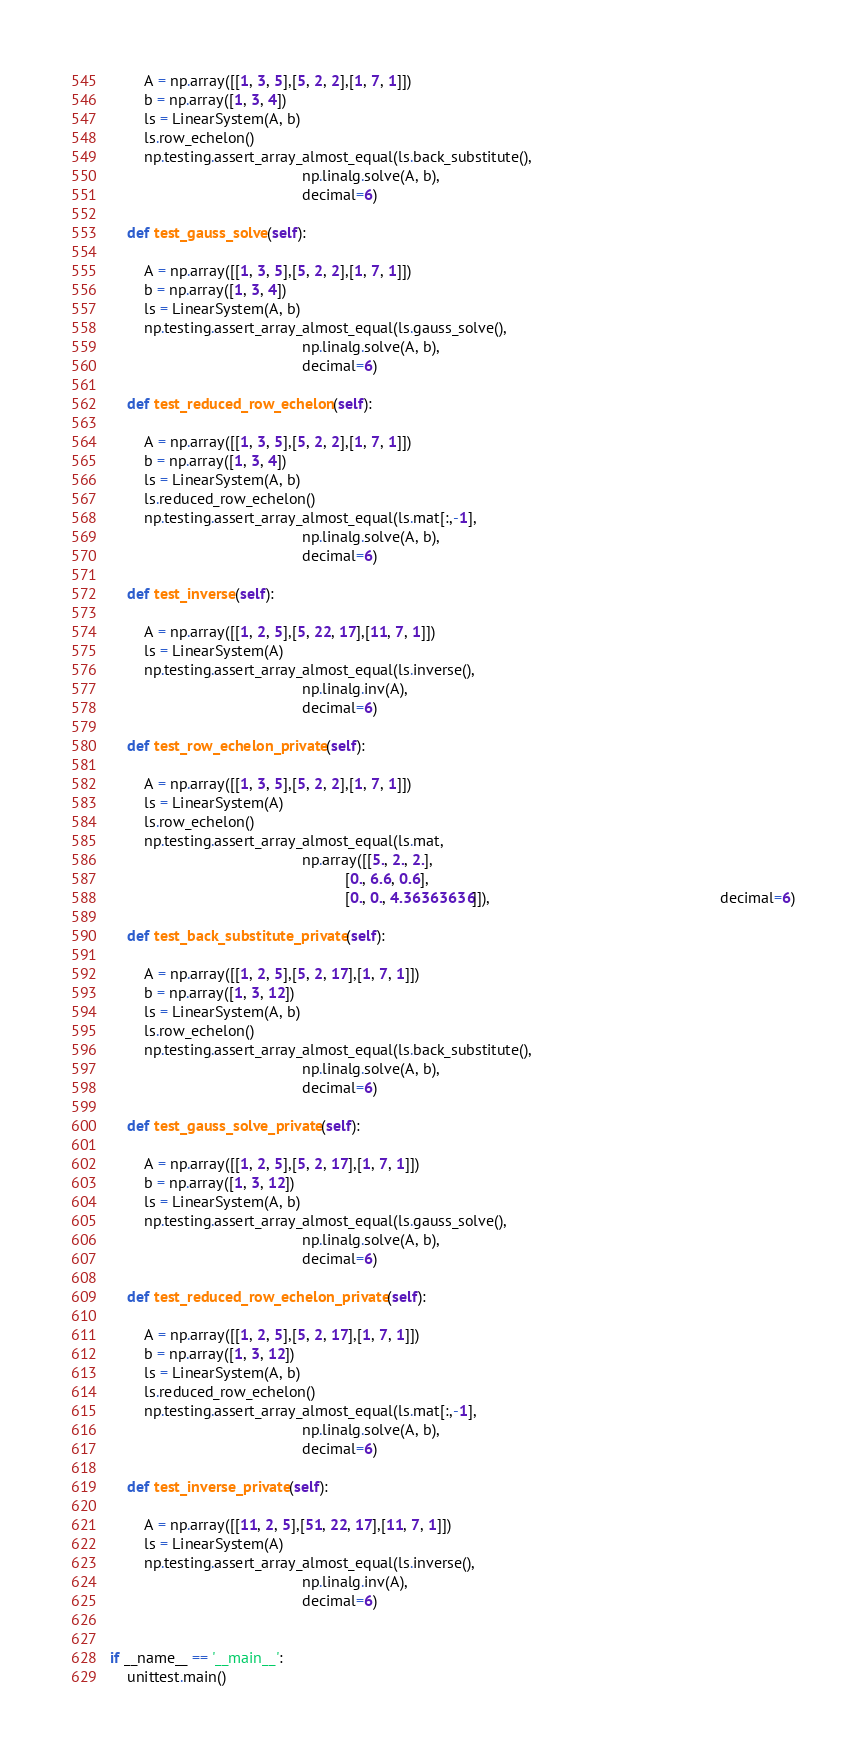Convert code to text. <code><loc_0><loc_0><loc_500><loc_500><_Python_>        A = np.array([[1, 3, 5],[5, 2, 2],[1, 7, 1]])
        b = np.array([1, 3, 4])
        ls = LinearSystem(A, b)
        ls.row_echelon()
        np.testing.assert_array_almost_equal(ls.back_substitute(),
                                             np.linalg.solve(A, b),
                                             decimal=6)
        
    def test_gauss_solve(self):
        
        A = np.array([[1, 3, 5],[5, 2, 2],[1, 7, 1]])
        b = np.array([1, 3, 4])
        ls = LinearSystem(A, b)
        np.testing.assert_array_almost_equal(ls.gauss_solve(),
                                             np.linalg.solve(A, b),
                                             decimal=6)
        
    def test_reduced_row_echelon(self):
        
        A = np.array([[1, 3, 5],[5, 2, 2],[1, 7, 1]])
        b = np.array([1, 3, 4])
        ls = LinearSystem(A, b)
        ls.reduced_row_echelon()
        np.testing.assert_array_almost_equal(ls.mat[:,-1],
                                             np.linalg.solve(A, b),
                                             decimal=6)
        
    def test_inverse(self):
        
        A = np.array([[1, 2, 5],[5, 22, 17],[11, 7, 1]])
        ls = LinearSystem(A)
        np.testing.assert_array_almost_equal(ls.inverse(),
                                             np.linalg.inv(A),
                                             decimal=6)
        
    def test_row_echelon_private(self):
        
        A = np.array([[1, 3, 5],[5, 2, 2],[1, 7, 1]])
        ls = LinearSystem(A)
        ls.row_echelon() 
        np.testing.assert_array_almost_equal(ls.mat, 
                                             np.array([[5., 2., 2.],
                                                       [0., 6.6, 0.6],
                                                       [0., 0., 4.36363636]]),                                                      decimal=6)
        
    def test_back_substitute_private(self):
        
        A = np.array([[1, 2, 5],[5, 2, 17],[1, 7, 1]])
        b = np.array([1, 3, 12])
        ls = LinearSystem(A, b)
        ls.row_echelon()
        np.testing.assert_array_almost_equal(ls.back_substitute(),
                                             np.linalg.solve(A, b),
                                             decimal=6)
        
    def test_gauss_solve_private(self):
        
        A = np.array([[1, 2, 5],[5, 2, 17],[1, 7, 1]])
        b = np.array([1, 3, 12])
        ls = LinearSystem(A, b)
        np.testing.assert_array_almost_equal(ls.gauss_solve(),
                                             np.linalg.solve(A, b),
                                             decimal=6)
        
    def test_reduced_row_echelon_private(self):
        
        A = np.array([[1, 2, 5],[5, 2, 17],[1, 7, 1]])
        b = np.array([1, 3, 12])
        ls = LinearSystem(A, b)
        ls.reduced_row_echelon()
        np.testing.assert_array_almost_equal(ls.mat[:,-1],
                                             np.linalg.solve(A, b),
                                             decimal=6)
        
    def test_inverse_private(self):
        
        A = np.array([[11, 2, 5],[51, 22, 17],[11, 7, 1]])
        ls = LinearSystem(A)
        np.testing.assert_array_almost_equal(ls.inverse(),
                                             np.linalg.inv(A),
                                             decimal=6)


if __name__ == '__main__':
    unittest.main()
</code> 